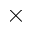Convert formula to latex. <formula><loc_0><loc_0><loc_500><loc_500>\times</formula> 